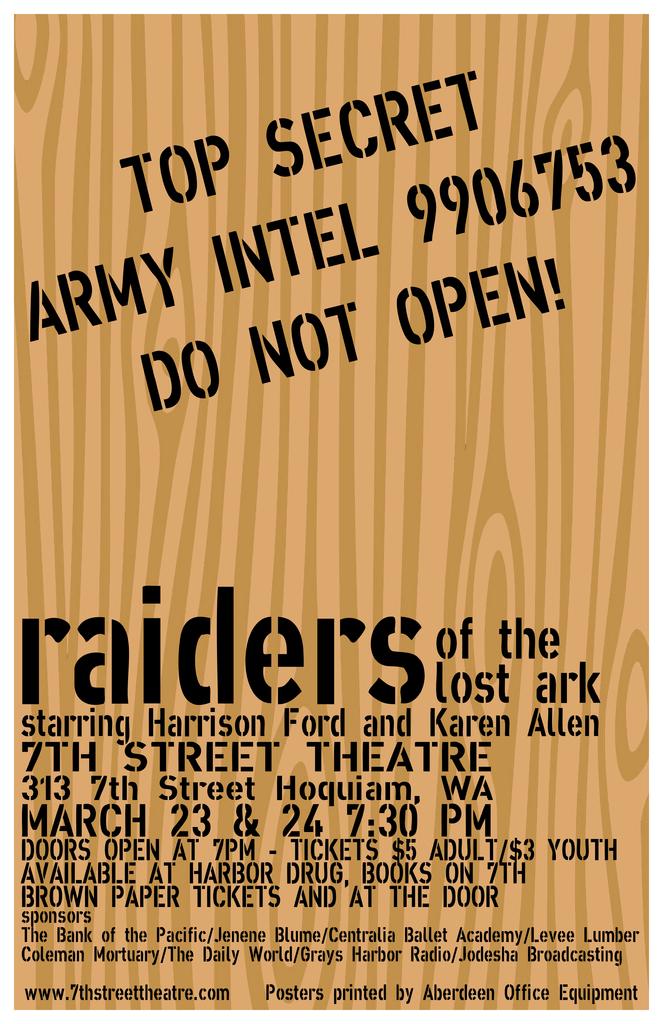Whos intel is in the book?
Keep it short and to the point. Army. What date and time is displayed?
Your answer should be compact. March 23 & 24 7:30 pm. 